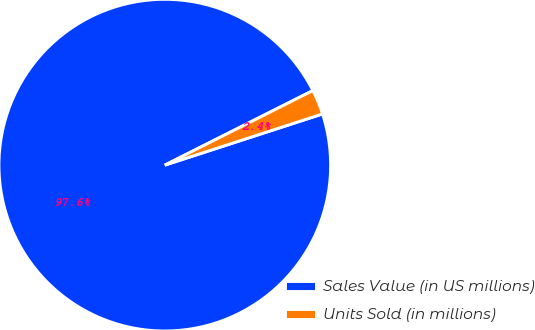Convert chart. <chart><loc_0><loc_0><loc_500><loc_500><pie_chart><fcel>Sales Value (in US millions)<fcel>Units Sold (in millions)<nl><fcel>97.57%<fcel>2.43%<nl></chart> 